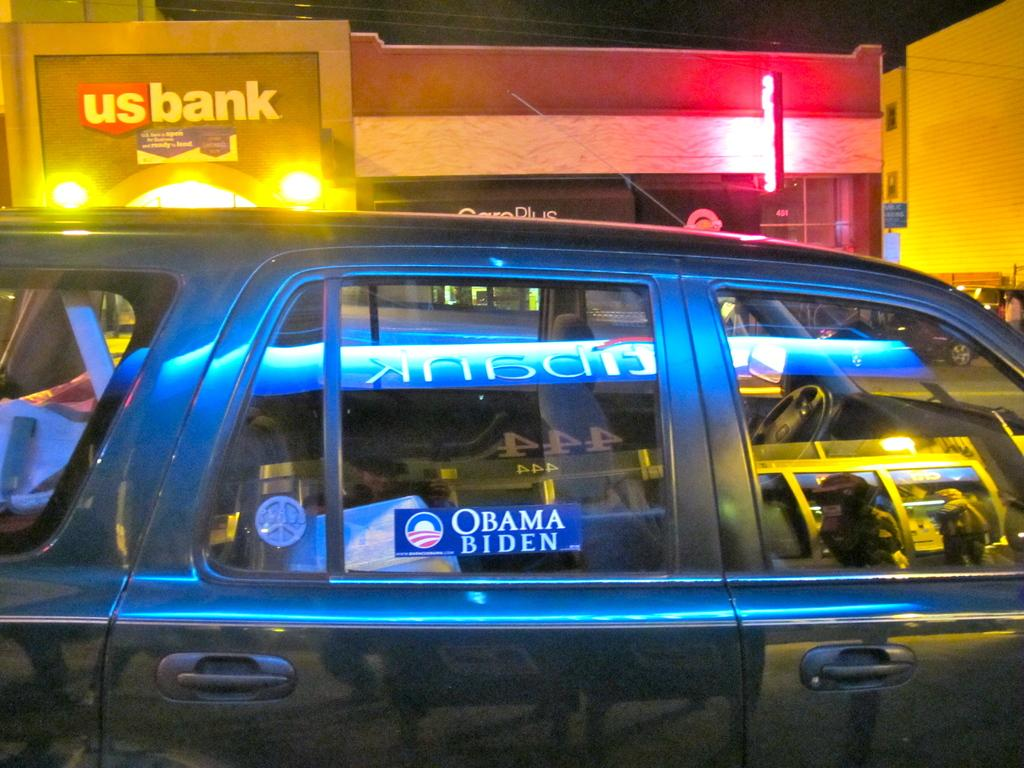<image>
Describe the image concisely. A car in front of a bank with an Obama-Biden sticker on it. 